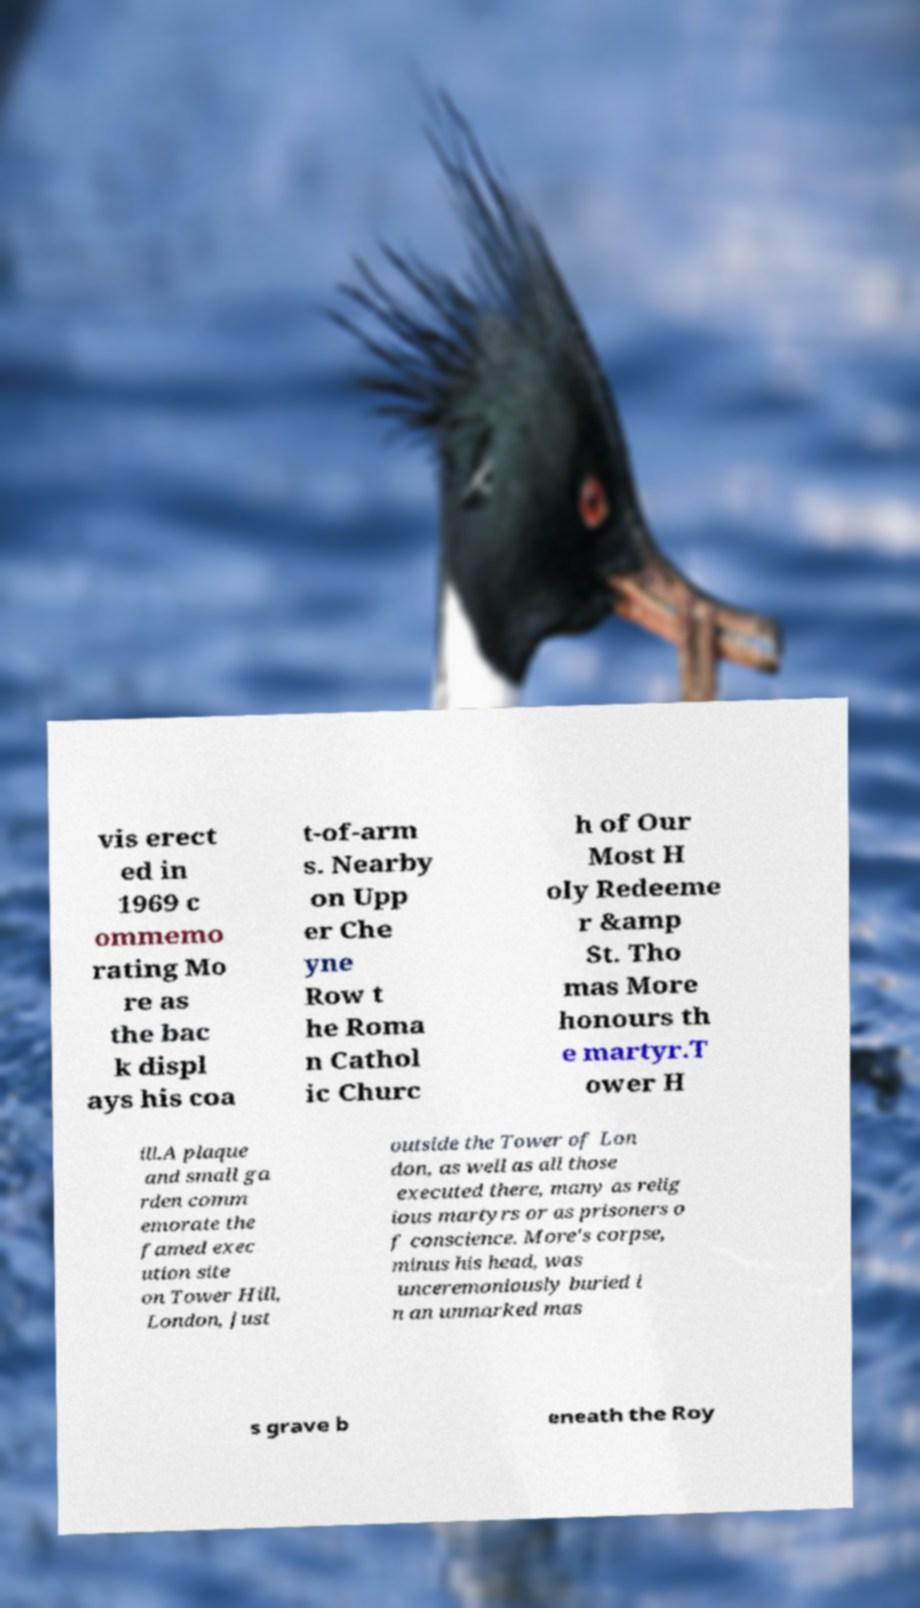Please read and relay the text visible in this image. What does it say? vis erect ed in 1969 c ommemo rating Mo re as the bac k displ ays his coa t-of-arm s. Nearby on Upp er Che yne Row t he Roma n Cathol ic Churc h of Our Most H oly Redeeme r &amp St. Tho mas More honours th e martyr.T ower H ill.A plaque and small ga rden comm emorate the famed exec ution site on Tower Hill, London, just outside the Tower of Lon don, as well as all those executed there, many as relig ious martyrs or as prisoners o f conscience. More's corpse, minus his head, was unceremoniously buried i n an unmarked mas s grave b eneath the Roy 